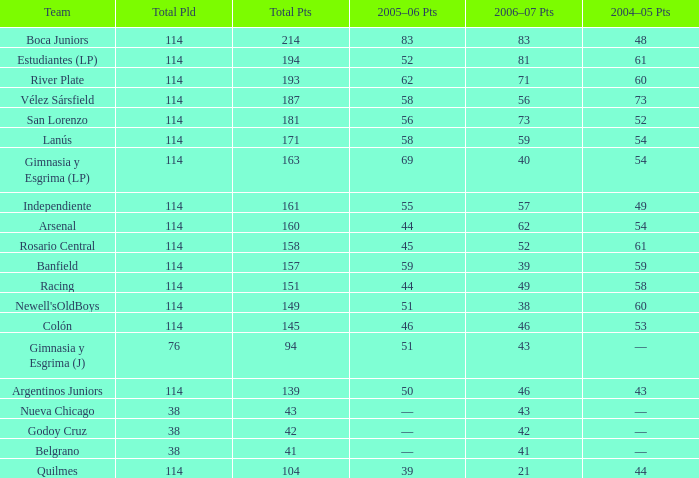What is the total number of PLD for Team Arsenal? 1.0. Can you parse all the data within this table? {'header': ['Team', 'Total Pld', 'Total Pts', '2005–06 Pts', '2006–07 Pts', '2004–05 Pts'], 'rows': [['Boca Juniors', '114', '214', '83', '83', '48'], ['Estudiantes (LP)', '114', '194', '52', '81', '61'], ['River Plate', '114', '193', '62', '71', '60'], ['Vélez Sársfield', '114', '187', '58', '56', '73'], ['San Lorenzo', '114', '181', '56', '73', '52'], ['Lanús', '114', '171', '58', '59', '54'], ['Gimnasia y Esgrima (LP)', '114', '163', '69', '40', '54'], ['Independiente', '114', '161', '55', '57', '49'], ['Arsenal', '114', '160', '44', '62', '54'], ['Rosario Central', '114', '158', '45', '52', '61'], ['Banfield', '114', '157', '59', '39', '59'], ['Racing', '114', '151', '44', '49', '58'], ["Newell'sOldBoys", '114', '149', '51', '38', '60'], ['Colón', '114', '145', '46', '46', '53'], ['Gimnasia y Esgrima (J)', '76', '94', '51', '43', '—'], ['Argentinos Juniors', '114', '139', '50', '46', '43'], ['Nueva Chicago', '38', '43', '—', '43', '—'], ['Godoy Cruz', '38', '42', '—', '42', '—'], ['Belgrano', '38', '41', '—', '41', '—'], ['Quilmes', '114', '104', '39', '21', '44']]} 